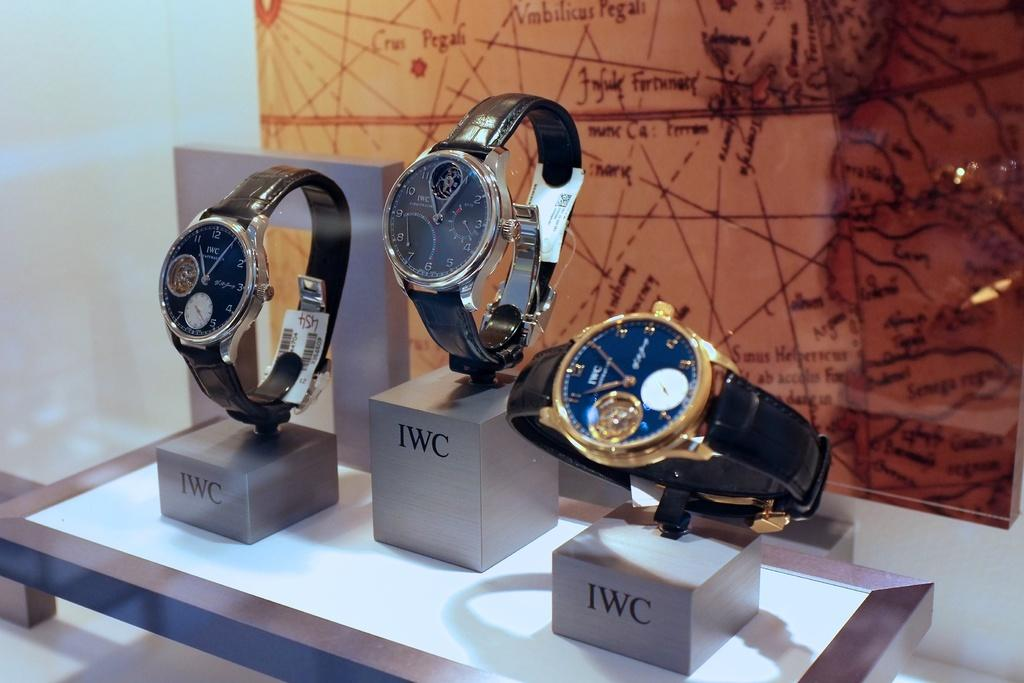<image>
Present a compact description of the photo's key features. 3 IWC wristwatches are on display boxes labeled IWC in front of a map. 